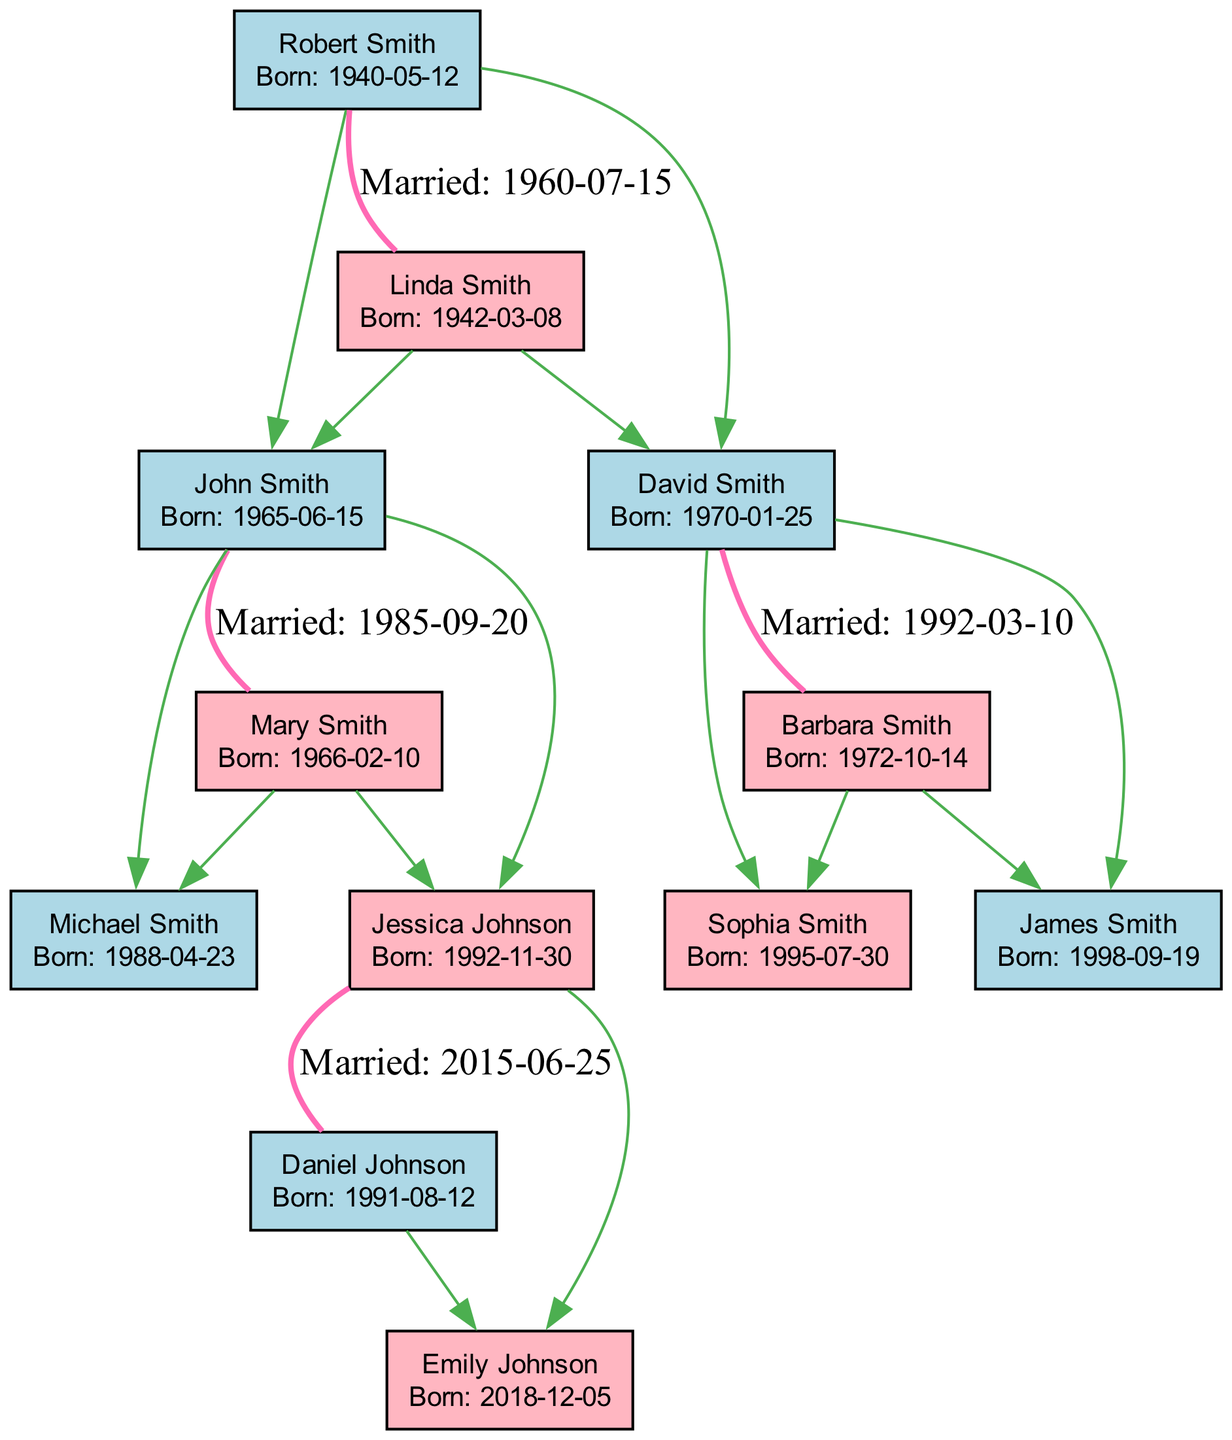What is the birth date of John Smith? The diagram lists John Smith's birth date clearly next to his name, shown as "Born: 1965-06-15".
Answer: 1965-06-15 How many children does Mary Smith have? By observing the connections in the diagram, Mary Smith has two children: Michael Smith and Jessica Johnson.
Answer: 2 Who is Jessica Johnson's spouse? The diagram indicates that Jessica Johnson is married to Daniel Johnson, connected through the marriage relationship labeled “Married: 2015-06-25”.
Answer: Daniel Johnson What year did David Smith marry Barbara Smith? The diagram shows the marriage connection between David Smith and Barbara Smith, with the date listed as "Married: 1992-03-10".
Answer: 1992 How many total individuals are in the family tree? Count the number of nodes (individuals) in the diagram, which includes John, Mary, Michael, Jessica, Daniel, Emily, Robert, Linda, David, and Barbara, totaling ten individuals.
Answer: 10 Which individual has the most children? By examining the diagram, Robert Smith and David Smith each have two children; however, the maximum from either one is still two children shown clearly under each.
Answer: Robert Smith What color is used for male individuals in the diagram? The diagram uses a light blue color (#ADD8E6) for male individuals, which can be easily seen from the color coding of the nodes.
Answer: Light blue How many generations are represented in the family tree? The diagram shows individuals of multiple ages, with Robert Smith as the oldest and Emily Johnson as the youngest, indicating three generations: grandparents, parents, and children.
Answer: 3 Which couple is connected by the edge labeled "Married"? The diagram shows multiple marriage connections including John and Mary Smith, Jessica and Daniel Johnson, Robert and Linda Smith, and David and Barbara Smith. The question can refer to any of these pairs that are connected by a marriage label.
Answer: John and Mary Smith 